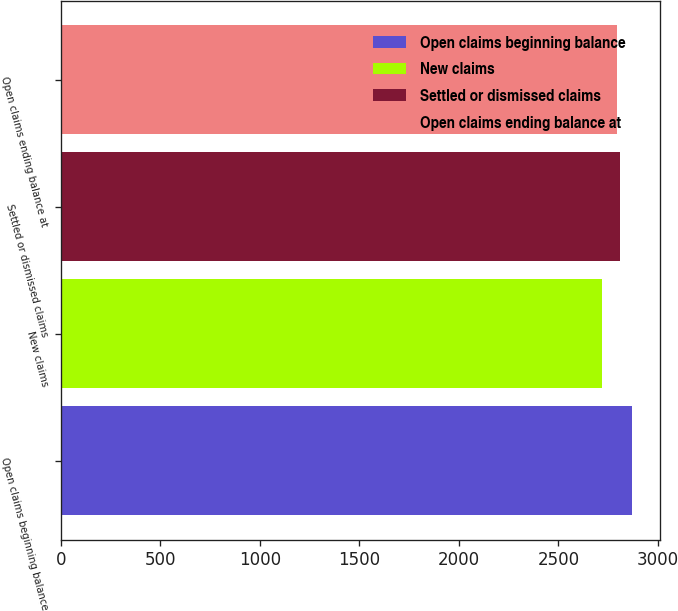Convert chart. <chart><loc_0><loc_0><loc_500><loc_500><bar_chart><fcel>Open claims beginning balance<fcel>New claims<fcel>Settled or dismissed claims<fcel>Open claims ending balance at<nl><fcel>2869<fcel>2719<fcel>2807<fcel>2792<nl></chart> 